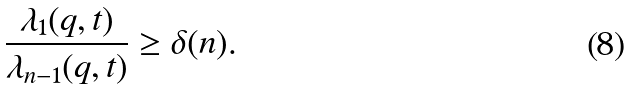<formula> <loc_0><loc_0><loc_500><loc_500>\frac { \lambda _ { 1 } ( q , t ) } { \lambda _ { n - 1 } ( q , t ) } \geq \delta ( n ) .</formula> 